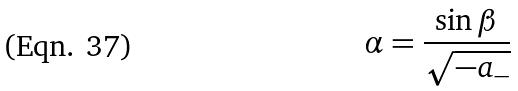Convert formula to latex. <formula><loc_0><loc_0><loc_500><loc_500>\alpha = \frac { \sin \beta } { \sqrt { - a _ { - } } }</formula> 